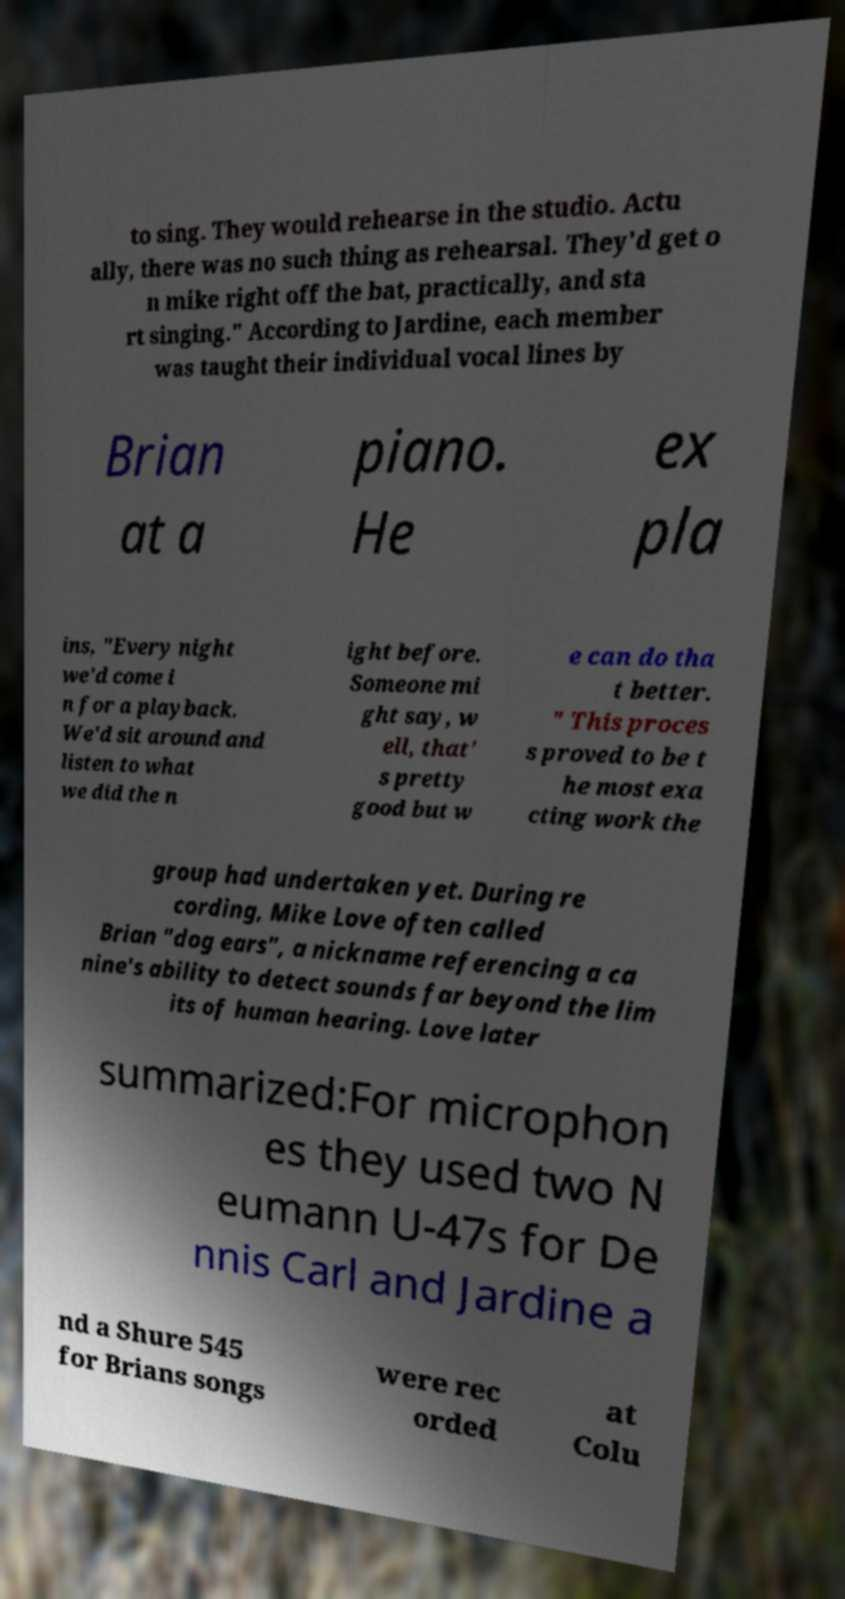Could you assist in decoding the text presented in this image and type it out clearly? to sing. They would rehearse in the studio. Actu ally, there was no such thing as rehearsal. They'd get o n mike right off the bat, practically, and sta rt singing." According to Jardine, each member was taught their individual vocal lines by Brian at a piano. He ex pla ins, "Every night we'd come i n for a playback. We'd sit around and listen to what we did the n ight before. Someone mi ght say, w ell, that' s pretty good but w e can do tha t better. " This proces s proved to be t he most exa cting work the group had undertaken yet. During re cording, Mike Love often called Brian "dog ears", a nickname referencing a ca nine's ability to detect sounds far beyond the lim its of human hearing. Love later summarized:For microphon es they used two N eumann U-47s for De nnis Carl and Jardine a nd a Shure 545 for Brians songs were rec orded at Colu 